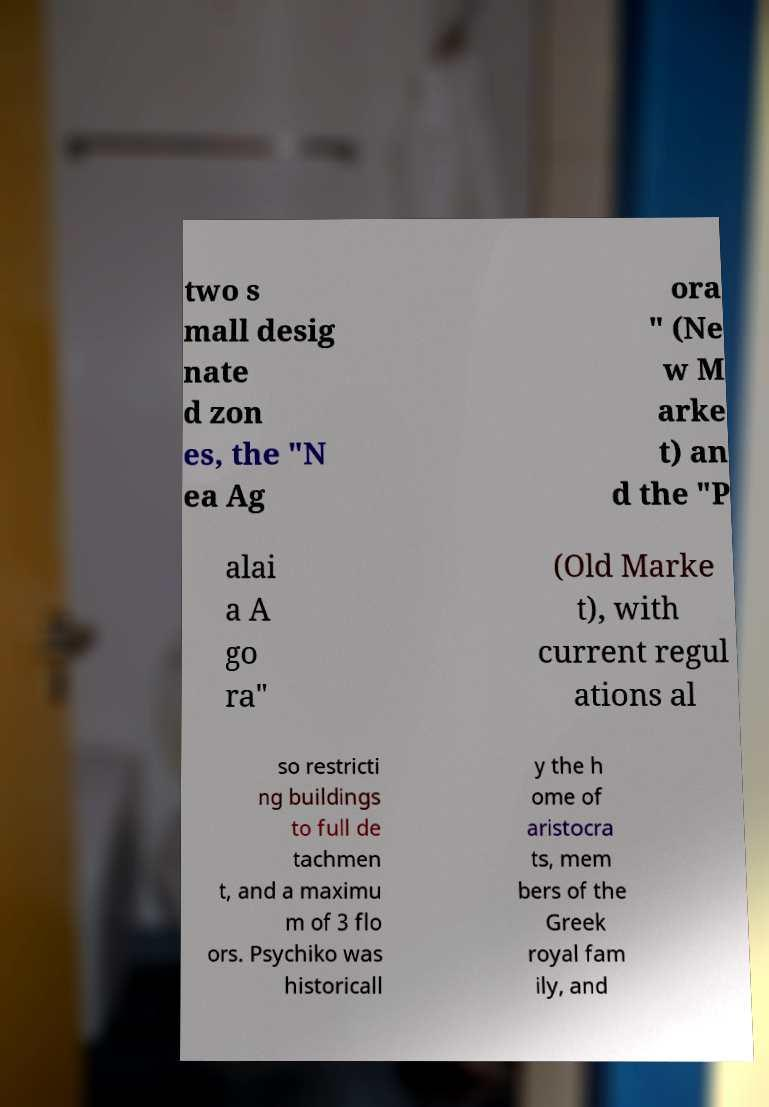Could you assist in decoding the text presented in this image and type it out clearly? two s mall desig nate d zon es, the "N ea Ag ora " (Ne w M arke t) an d the "P alai a A go ra" (Old Marke t), with current regul ations al so restricti ng buildings to full de tachmen t, and a maximu m of 3 flo ors. Psychiko was historicall y the h ome of aristocra ts, mem bers of the Greek royal fam ily, and 